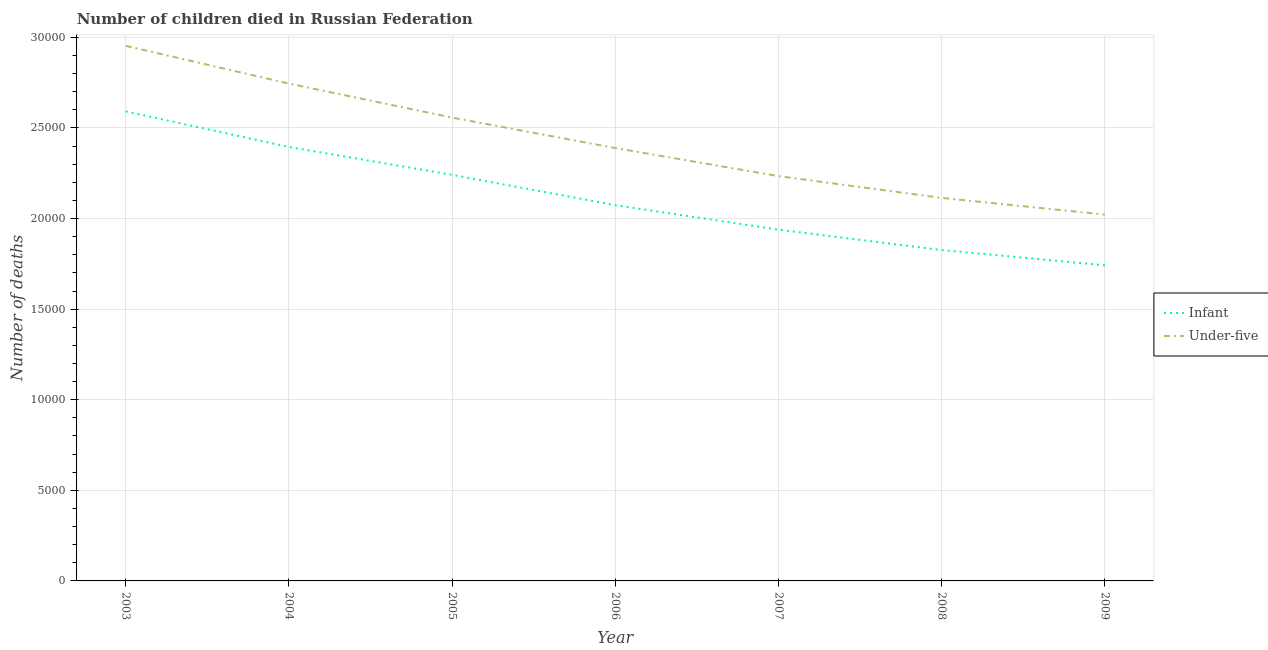How many different coloured lines are there?
Provide a short and direct response. 2. Does the line corresponding to number of under-five deaths intersect with the line corresponding to number of infant deaths?
Offer a very short reply. No. Is the number of lines equal to the number of legend labels?
Your answer should be very brief. Yes. What is the number of infant deaths in 2007?
Make the answer very short. 1.94e+04. Across all years, what is the maximum number of infant deaths?
Make the answer very short. 2.59e+04. Across all years, what is the minimum number of infant deaths?
Offer a terse response. 1.74e+04. In which year was the number of under-five deaths maximum?
Your response must be concise. 2003. What is the total number of infant deaths in the graph?
Your response must be concise. 1.48e+05. What is the difference between the number of infant deaths in 2004 and that in 2005?
Provide a succinct answer. 1540. What is the difference between the number of infant deaths in 2004 and the number of under-five deaths in 2006?
Offer a terse response. 60. What is the average number of under-five deaths per year?
Keep it short and to the point. 2.43e+04. In the year 2003, what is the difference between the number of infant deaths and number of under-five deaths?
Your answer should be compact. -3618. In how many years, is the number of infant deaths greater than 10000?
Ensure brevity in your answer.  7. What is the ratio of the number of under-five deaths in 2004 to that in 2008?
Give a very brief answer. 1.3. Is the difference between the number of infant deaths in 2008 and 2009 greater than the difference between the number of under-five deaths in 2008 and 2009?
Provide a succinct answer. No. What is the difference between the highest and the second highest number of under-five deaths?
Your response must be concise. 2083. What is the difference between the highest and the lowest number of infant deaths?
Make the answer very short. 8495. In how many years, is the number of infant deaths greater than the average number of infant deaths taken over all years?
Offer a terse response. 3. Is the sum of the number of under-five deaths in 2006 and 2007 greater than the maximum number of infant deaths across all years?
Give a very brief answer. Yes. Does the number of under-five deaths monotonically increase over the years?
Ensure brevity in your answer.  No. Is the number of infant deaths strictly greater than the number of under-five deaths over the years?
Offer a terse response. No. Is the number of under-five deaths strictly less than the number of infant deaths over the years?
Your answer should be compact. No. How many lines are there?
Provide a short and direct response. 2. How many years are there in the graph?
Offer a very short reply. 7. Are the values on the major ticks of Y-axis written in scientific E-notation?
Provide a succinct answer. No. Where does the legend appear in the graph?
Provide a succinct answer. Center right. How are the legend labels stacked?
Your response must be concise. Vertical. What is the title of the graph?
Keep it short and to the point. Number of children died in Russian Federation. What is the label or title of the Y-axis?
Make the answer very short. Number of deaths. What is the Number of deaths in Infant in 2003?
Keep it short and to the point. 2.59e+04. What is the Number of deaths of Under-five in 2003?
Your response must be concise. 2.95e+04. What is the Number of deaths of Infant in 2004?
Offer a terse response. 2.40e+04. What is the Number of deaths in Under-five in 2004?
Give a very brief answer. 2.75e+04. What is the Number of deaths of Infant in 2005?
Provide a succinct answer. 2.24e+04. What is the Number of deaths in Under-five in 2005?
Make the answer very short. 2.56e+04. What is the Number of deaths in Infant in 2006?
Your answer should be compact. 2.07e+04. What is the Number of deaths in Under-five in 2006?
Make the answer very short. 2.39e+04. What is the Number of deaths in Infant in 2007?
Offer a very short reply. 1.94e+04. What is the Number of deaths of Under-five in 2007?
Provide a succinct answer. 2.23e+04. What is the Number of deaths in Infant in 2008?
Give a very brief answer. 1.83e+04. What is the Number of deaths of Under-five in 2008?
Your response must be concise. 2.11e+04. What is the Number of deaths of Infant in 2009?
Your answer should be compact. 1.74e+04. What is the Number of deaths in Under-five in 2009?
Ensure brevity in your answer.  2.02e+04. Across all years, what is the maximum Number of deaths in Infant?
Your response must be concise. 2.59e+04. Across all years, what is the maximum Number of deaths of Under-five?
Provide a short and direct response. 2.95e+04. Across all years, what is the minimum Number of deaths in Infant?
Keep it short and to the point. 1.74e+04. Across all years, what is the minimum Number of deaths in Under-five?
Keep it short and to the point. 2.02e+04. What is the total Number of deaths in Infant in the graph?
Give a very brief answer. 1.48e+05. What is the total Number of deaths in Under-five in the graph?
Your answer should be compact. 1.70e+05. What is the difference between the Number of deaths in Infant in 2003 and that in 2004?
Your response must be concise. 1963. What is the difference between the Number of deaths in Under-five in 2003 and that in 2004?
Provide a succinct answer. 2083. What is the difference between the Number of deaths in Infant in 2003 and that in 2005?
Ensure brevity in your answer.  3503. What is the difference between the Number of deaths of Under-five in 2003 and that in 2005?
Keep it short and to the point. 3961. What is the difference between the Number of deaths in Infant in 2003 and that in 2006?
Offer a very short reply. 5177. What is the difference between the Number of deaths of Under-five in 2003 and that in 2006?
Your answer should be very brief. 5641. What is the difference between the Number of deaths of Infant in 2003 and that in 2007?
Offer a very short reply. 6528. What is the difference between the Number of deaths in Under-five in 2003 and that in 2007?
Give a very brief answer. 7191. What is the difference between the Number of deaths in Infant in 2003 and that in 2008?
Your answer should be very brief. 7654. What is the difference between the Number of deaths in Under-five in 2003 and that in 2008?
Provide a short and direct response. 8393. What is the difference between the Number of deaths in Infant in 2003 and that in 2009?
Give a very brief answer. 8495. What is the difference between the Number of deaths in Under-five in 2003 and that in 2009?
Your answer should be compact. 9313. What is the difference between the Number of deaths of Infant in 2004 and that in 2005?
Give a very brief answer. 1540. What is the difference between the Number of deaths in Under-five in 2004 and that in 2005?
Provide a short and direct response. 1878. What is the difference between the Number of deaths of Infant in 2004 and that in 2006?
Your answer should be very brief. 3214. What is the difference between the Number of deaths in Under-five in 2004 and that in 2006?
Your answer should be very brief. 3558. What is the difference between the Number of deaths in Infant in 2004 and that in 2007?
Ensure brevity in your answer.  4565. What is the difference between the Number of deaths of Under-five in 2004 and that in 2007?
Give a very brief answer. 5108. What is the difference between the Number of deaths in Infant in 2004 and that in 2008?
Ensure brevity in your answer.  5691. What is the difference between the Number of deaths in Under-five in 2004 and that in 2008?
Offer a terse response. 6310. What is the difference between the Number of deaths in Infant in 2004 and that in 2009?
Provide a short and direct response. 6532. What is the difference between the Number of deaths in Under-five in 2004 and that in 2009?
Provide a succinct answer. 7230. What is the difference between the Number of deaths of Infant in 2005 and that in 2006?
Offer a terse response. 1674. What is the difference between the Number of deaths of Under-five in 2005 and that in 2006?
Offer a very short reply. 1680. What is the difference between the Number of deaths in Infant in 2005 and that in 2007?
Your answer should be very brief. 3025. What is the difference between the Number of deaths of Under-five in 2005 and that in 2007?
Keep it short and to the point. 3230. What is the difference between the Number of deaths in Infant in 2005 and that in 2008?
Your response must be concise. 4151. What is the difference between the Number of deaths of Under-five in 2005 and that in 2008?
Ensure brevity in your answer.  4432. What is the difference between the Number of deaths of Infant in 2005 and that in 2009?
Provide a succinct answer. 4992. What is the difference between the Number of deaths in Under-five in 2005 and that in 2009?
Your response must be concise. 5352. What is the difference between the Number of deaths of Infant in 2006 and that in 2007?
Keep it short and to the point. 1351. What is the difference between the Number of deaths in Under-five in 2006 and that in 2007?
Provide a succinct answer. 1550. What is the difference between the Number of deaths in Infant in 2006 and that in 2008?
Offer a very short reply. 2477. What is the difference between the Number of deaths of Under-five in 2006 and that in 2008?
Ensure brevity in your answer.  2752. What is the difference between the Number of deaths of Infant in 2006 and that in 2009?
Provide a short and direct response. 3318. What is the difference between the Number of deaths of Under-five in 2006 and that in 2009?
Make the answer very short. 3672. What is the difference between the Number of deaths of Infant in 2007 and that in 2008?
Give a very brief answer. 1126. What is the difference between the Number of deaths of Under-five in 2007 and that in 2008?
Provide a short and direct response. 1202. What is the difference between the Number of deaths of Infant in 2007 and that in 2009?
Offer a terse response. 1967. What is the difference between the Number of deaths of Under-five in 2007 and that in 2009?
Offer a very short reply. 2122. What is the difference between the Number of deaths of Infant in 2008 and that in 2009?
Offer a terse response. 841. What is the difference between the Number of deaths of Under-five in 2008 and that in 2009?
Provide a short and direct response. 920. What is the difference between the Number of deaths of Infant in 2003 and the Number of deaths of Under-five in 2004?
Your answer should be compact. -1535. What is the difference between the Number of deaths in Infant in 2003 and the Number of deaths in Under-five in 2005?
Keep it short and to the point. 343. What is the difference between the Number of deaths in Infant in 2003 and the Number of deaths in Under-five in 2006?
Your answer should be compact. 2023. What is the difference between the Number of deaths in Infant in 2003 and the Number of deaths in Under-five in 2007?
Give a very brief answer. 3573. What is the difference between the Number of deaths of Infant in 2003 and the Number of deaths of Under-five in 2008?
Your answer should be compact. 4775. What is the difference between the Number of deaths in Infant in 2003 and the Number of deaths in Under-five in 2009?
Make the answer very short. 5695. What is the difference between the Number of deaths of Infant in 2004 and the Number of deaths of Under-five in 2005?
Provide a succinct answer. -1620. What is the difference between the Number of deaths of Infant in 2004 and the Number of deaths of Under-five in 2007?
Your answer should be very brief. 1610. What is the difference between the Number of deaths of Infant in 2004 and the Number of deaths of Under-five in 2008?
Your answer should be very brief. 2812. What is the difference between the Number of deaths of Infant in 2004 and the Number of deaths of Under-five in 2009?
Provide a short and direct response. 3732. What is the difference between the Number of deaths in Infant in 2005 and the Number of deaths in Under-five in 2006?
Offer a terse response. -1480. What is the difference between the Number of deaths in Infant in 2005 and the Number of deaths in Under-five in 2008?
Your response must be concise. 1272. What is the difference between the Number of deaths in Infant in 2005 and the Number of deaths in Under-five in 2009?
Provide a short and direct response. 2192. What is the difference between the Number of deaths in Infant in 2006 and the Number of deaths in Under-five in 2007?
Your answer should be compact. -1604. What is the difference between the Number of deaths of Infant in 2006 and the Number of deaths of Under-five in 2008?
Offer a terse response. -402. What is the difference between the Number of deaths of Infant in 2006 and the Number of deaths of Under-five in 2009?
Make the answer very short. 518. What is the difference between the Number of deaths in Infant in 2007 and the Number of deaths in Under-five in 2008?
Your response must be concise. -1753. What is the difference between the Number of deaths in Infant in 2007 and the Number of deaths in Under-five in 2009?
Keep it short and to the point. -833. What is the difference between the Number of deaths in Infant in 2008 and the Number of deaths in Under-five in 2009?
Offer a very short reply. -1959. What is the average Number of deaths in Infant per year?
Offer a very short reply. 2.12e+04. What is the average Number of deaths in Under-five per year?
Your response must be concise. 2.43e+04. In the year 2003, what is the difference between the Number of deaths in Infant and Number of deaths in Under-five?
Make the answer very short. -3618. In the year 2004, what is the difference between the Number of deaths in Infant and Number of deaths in Under-five?
Make the answer very short. -3498. In the year 2005, what is the difference between the Number of deaths in Infant and Number of deaths in Under-five?
Your answer should be compact. -3160. In the year 2006, what is the difference between the Number of deaths of Infant and Number of deaths of Under-five?
Make the answer very short. -3154. In the year 2007, what is the difference between the Number of deaths of Infant and Number of deaths of Under-five?
Provide a succinct answer. -2955. In the year 2008, what is the difference between the Number of deaths of Infant and Number of deaths of Under-five?
Provide a short and direct response. -2879. In the year 2009, what is the difference between the Number of deaths in Infant and Number of deaths in Under-five?
Provide a succinct answer. -2800. What is the ratio of the Number of deaths of Infant in 2003 to that in 2004?
Offer a very short reply. 1.08. What is the ratio of the Number of deaths in Under-five in 2003 to that in 2004?
Make the answer very short. 1.08. What is the ratio of the Number of deaths of Infant in 2003 to that in 2005?
Ensure brevity in your answer.  1.16. What is the ratio of the Number of deaths of Under-five in 2003 to that in 2005?
Offer a terse response. 1.15. What is the ratio of the Number of deaths in Infant in 2003 to that in 2006?
Your answer should be very brief. 1.25. What is the ratio of the Number of deaths of Under-five in 2003 to that in 2006?
Keep it short and to the point. 1.24. What is the ratio of the Number of deaths of Infant in 2003 to that in 2007?
Keep it short and to the point. 1.34. What is the ratio of the Number of deaths in Under-five in 2003 to that in 2007?
Provide a succinct answer. 1.32. What is the ratio of the Number of deaths in Infant in 2003 to that in 2008?
Make the answer very short. 1.42. What is the ratio of the Number of deaths in Under-five in 2003 to that in 2008?
Offer a terse response. 1.4. What is the ratio of the Number of deaths of Infant in 2003 to that in 2009?
Keep it short and to the point. 1.49. What is the ratio of the Number of deaths of Under-five in 2003 to that in 2009?
Keep it short and to the point. 1.46. What is the ratio of the Number of deaths in Infant in 2004 to that in 2005?
Your answer should be very brief. 1.07. What is the ratio of the Number of deaths in Under-five in 2004 to that in 2005?
Offer a very short reply. 1.07. What is the ratio of the Number of deaths of Infant in 2004 to that in 2006?
Ensure brevity in your answer.  1.16. What is the ratio of the Number of deaths of Under-five in 2004 to that in 2006?
Make the answer very short. 1.15. What is the ratio of the Number of deaths in Infant in 2004 to that in 2007?
Offer a very short reply. 1.24. What is the ratio of the Number of deaths in Under-five in 2004 to that in 2007?
Make the answer very short. 1.23. What is the ratio of the Number of deaths of Infant in 2004 to that in 2008?
Give a very brief answer. 1.31. What is the ratio of the Number of deaths in Under-five in 2004 to that in 2008?
Offer a terse response. 1.3. What is the ratio of the Number of deaths of Infant in 2004 to that in 2009?
Give a very brief answer. 1.37. What is the ratio of the Number of deaths of Under-five in 2004 to that in 2009?
Give a very brief answer. 1.36. What is the ratio of the Number of deaths of Infant in 2005 to that in 2006?
Give a very brief answer. 1.08. What is the ratio of the Number of deaths in Under-five in 2005 to that in 2006?
Provide a short and direct response. 1.07. What is the ratio of the Number of deaths in Infant in 2005 to that in 2007?
Offer a very short reply. 1.16. What is the ratio of the Number of deaths of Under-five in 2005 to that in 2007?
Your answer should be compact. 1.14. What is the ratio of the Number of deaths in Infant in 2005 to that in 2008?
Your answer should be compact. 1.23. What is the ratio of the Number of deaths of Under-five in 2005 to that in 2008?
Your response must be concise. 1.21. What is the ratio of the Number of deaths of Infant in 2005 to that in 2009?
Offer a terse response. 1.29. What is the ratio of the Number of deaths of Under-five in 2005 to that in 2009?
Keep it short and to the point. 1.26. What is the ratio of the Number of deaths of Infant in 2006 to that in 2007?
Offer a very short reply. 1.07. What is the ratio of the Number of deaths in Under-five in 2006 to that in 2007?
Offer a terse response. 1.07. What is the ratio of the Number of deaths of Infant in 2006 to that in 2008?
Keep it short and to the point. 1.14. What is the ratio of the Number of deaths of Under-five in 2006 to that in 2008?
Provide a succinct answer. 1.13. What is the ratio of the Number of deaths in Infant in 2006 to that in 2009?
Give a very brief answer. 1.19. What is the ratio of the Number of deaths of Under-five in 2006 to that in 2009?
Your answer should be very brief. 1.18. What is the ratio of the Number of deaths in Infant in 2007 to that in 2008?
Your response must be concise. 1.06. What is the ratio of the Number of deaths of Under-five in 2007 to that in 2008?
Offer a very short reply. 1.06. What is the ratio of the Number of deaths of Infant in 2007 to that in 2009?
Offer a terse response. 1.11. What is the ratio of the Number of deaths in Under-five in 2007 to that in 2009?
Keep it short and to the point. 1.1. What is the ratio of the Number of deaths of Infant in 2008 to that in 2009?
Offer a very short reply. 1.05. What is the ratio of the Number of deaths in Under-five in 2008 to that in 2009?
Offer a very short reply. 1.05. What is the difference between the highest and the second highest Number of deaths of Infant?
Offer a terse response. 1963. What is the difference between the highest and the second highest Number of deaths in Under-five?
Make the answer very short. 2083. What is the difference between the highest and the lowest Number of deaths of Infant?
Your answer should be compact. 8495. What is the difference between the highest and the lowest Number of deaths in Under-five?
Give a very brief answer. 9313. 